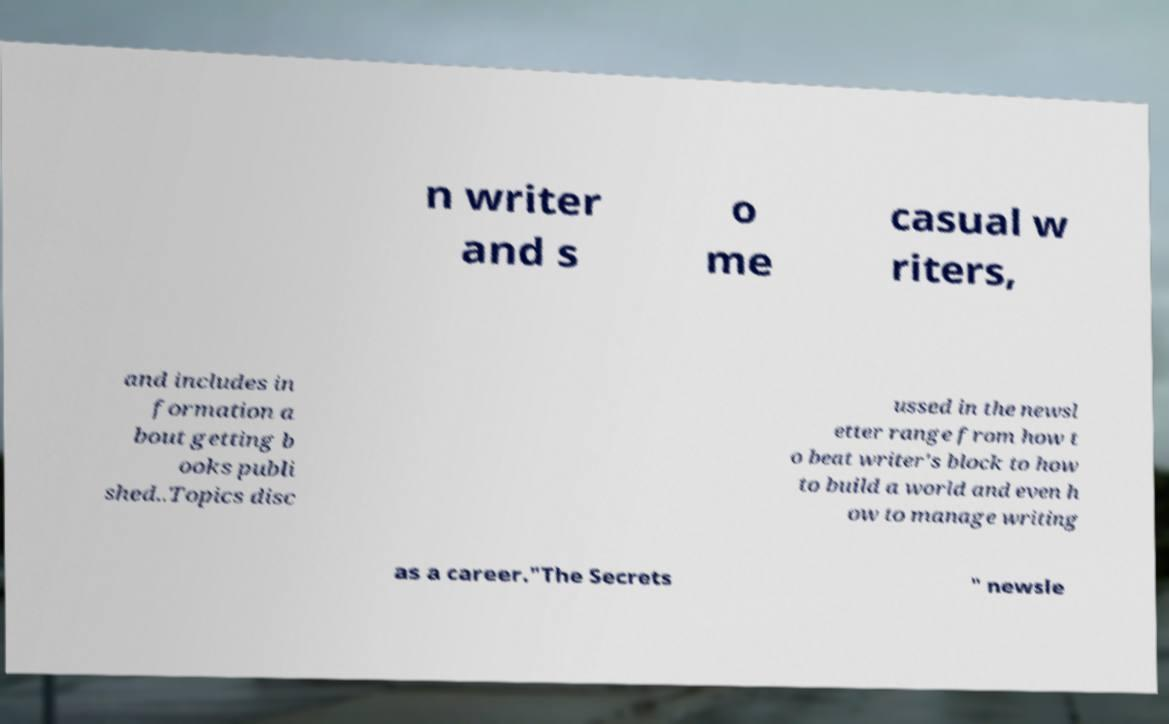Please read and relay the text visible in this image. What does it say? n writer and s o me casual w riters, and includes in formation a bout getting b ooks publi shed..Topics disc ussed in the newsl etter range from how t o beat writer's block to how to build a world and even h ow to manage writing as a career."The Secrets " newsle 